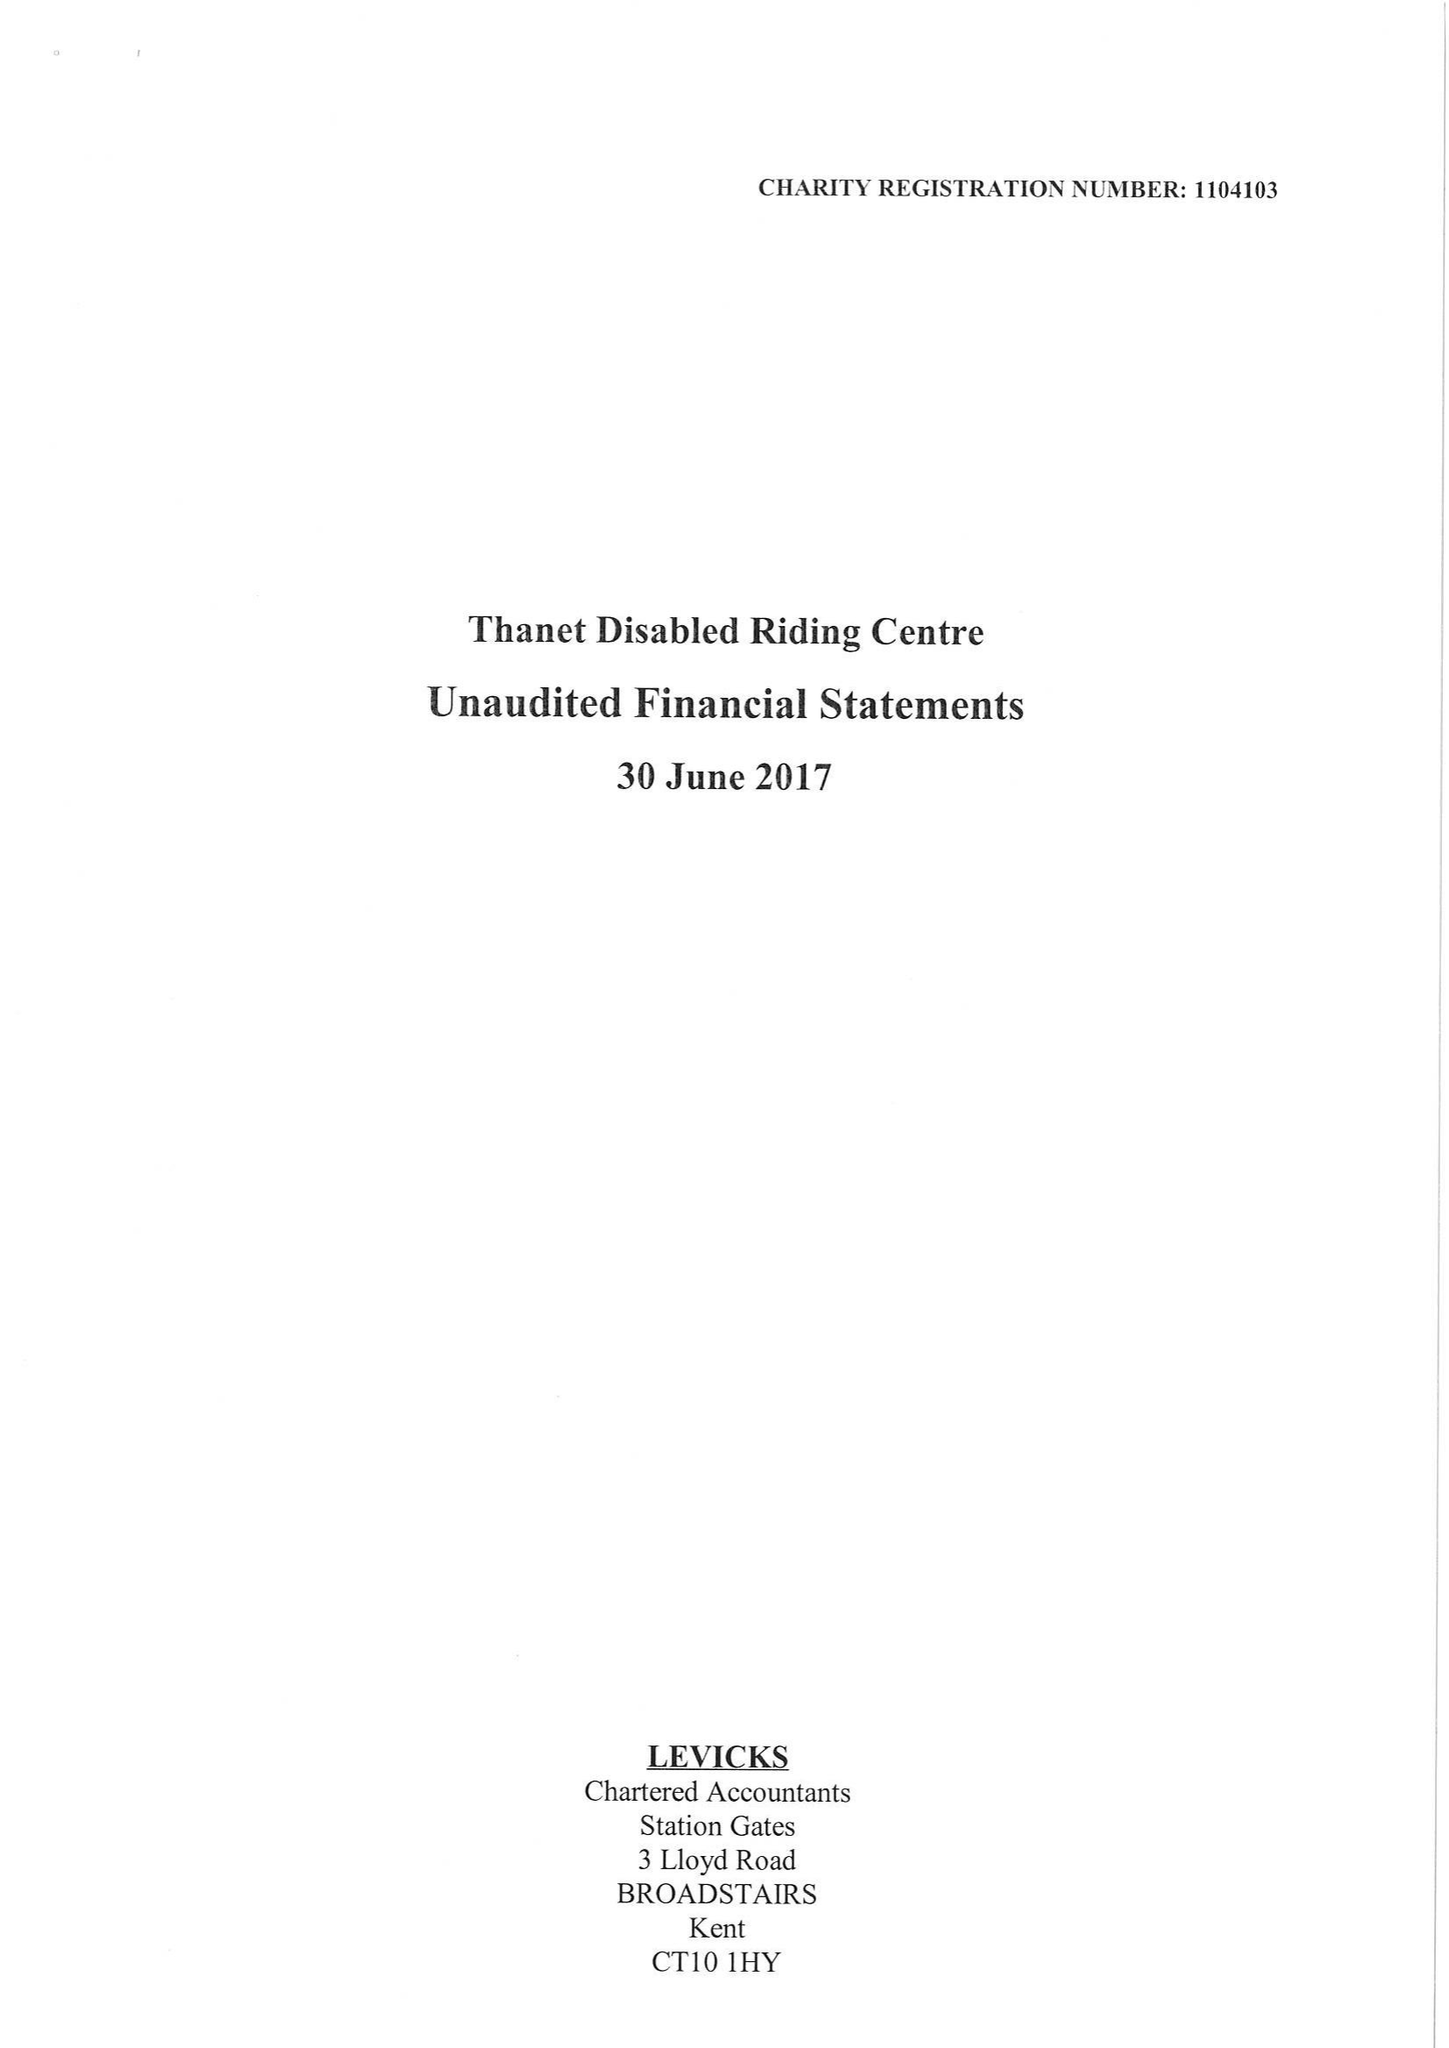What is the value for the address__street_line?
Answer the question using a single word or phrase. CALLIS COURT ROAD 